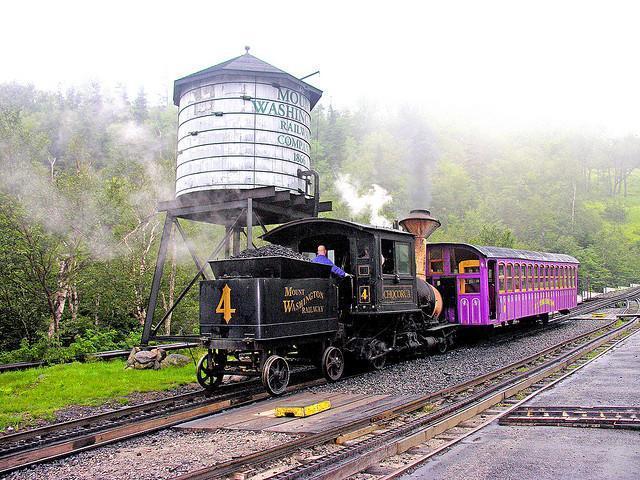How many blue skis are there?
Give a very brief answer. 0. 